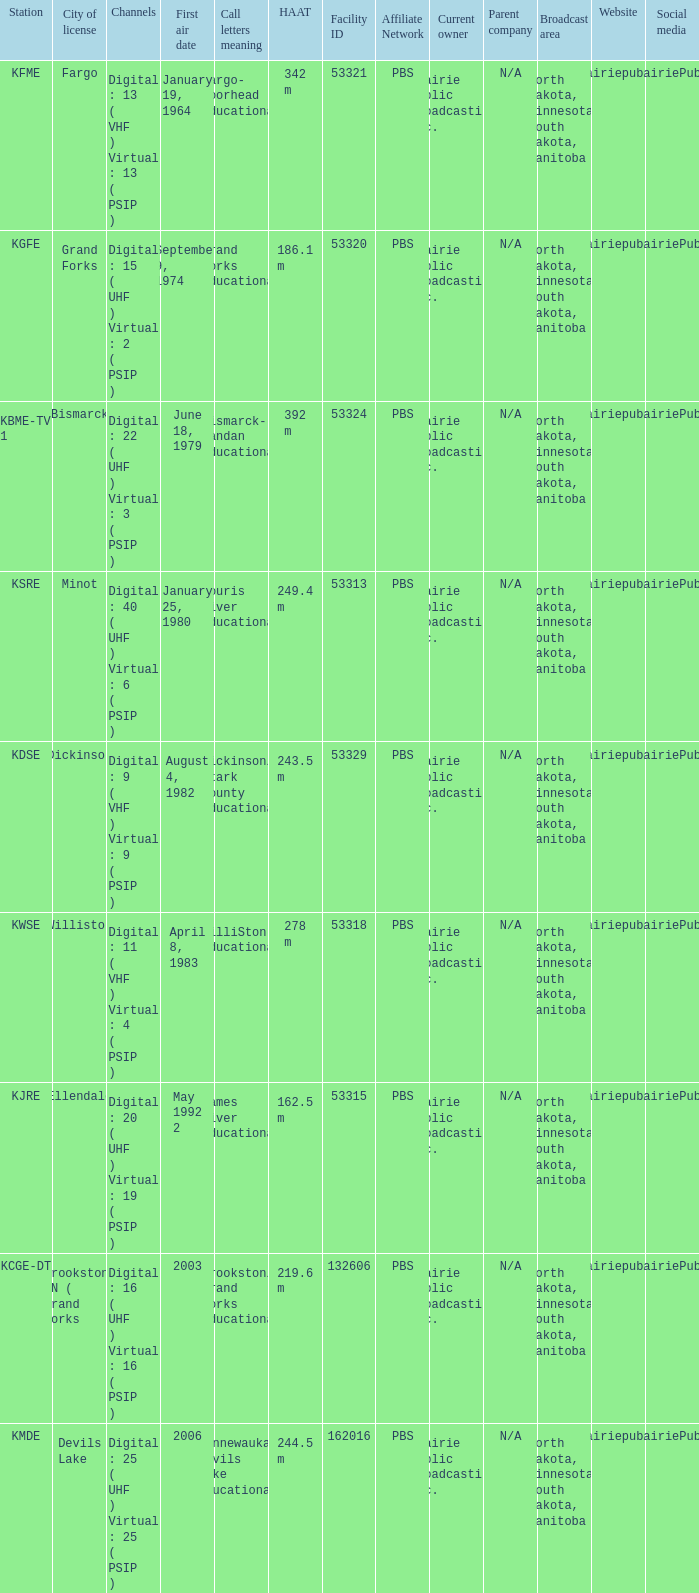What is the haat of devils lake 244.5 m. 